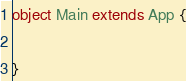Convert code to text. <code><loc_0><loc_0><loc_500><loc_500><_Scala_>object Main extends App {

}</code> 